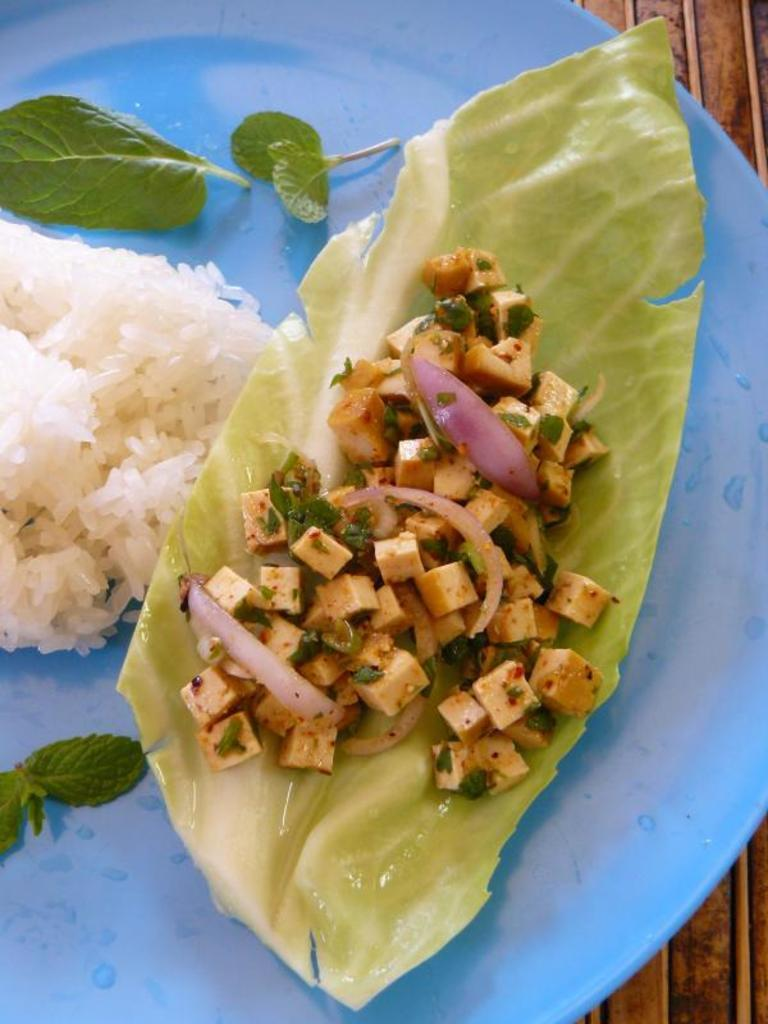What type of food can be seen in the image? There is rice and other food in the image. What color is the plate that holds the food? The plate is blue in color. What type of umbrella is being used to cover the food in the image? There is no umbrella present in the image; it is a plate of food with no coverings. 